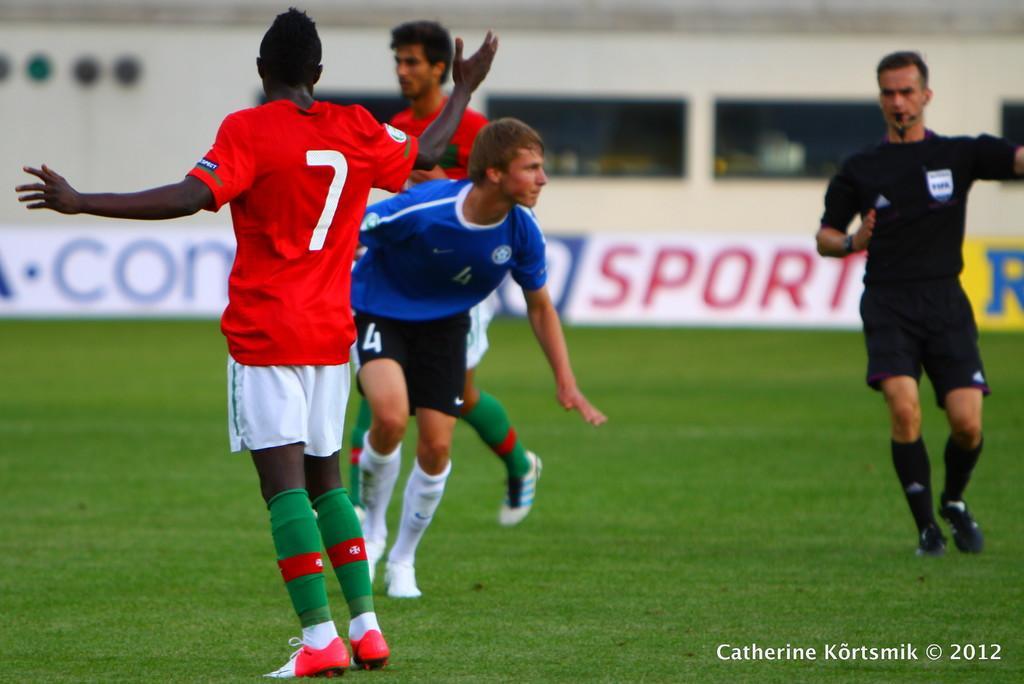Describe this image in one or two sentences. In this picture I can observe four members in the ground. They are wearing red, blue and black color jerseys. One of them is holding a whistle in his mouth. In the bottom right side I can observe some text. 